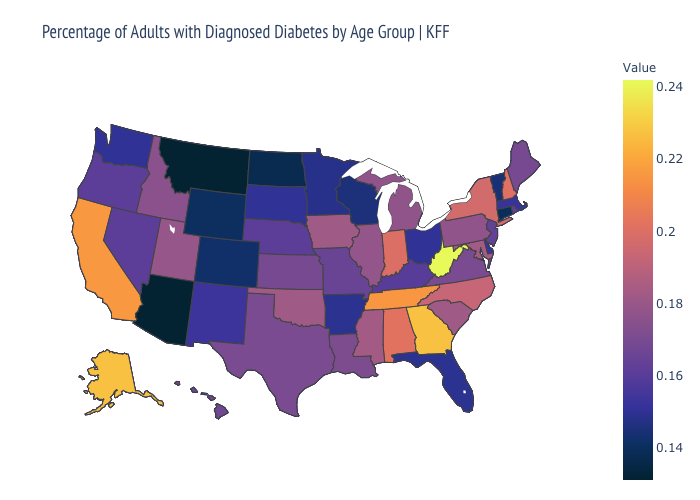Which states have the lowest value in the USA?
Give a very brief answer. Arizona, Montana. Among the states that border Florida , which have the lowest value?
Short answer required. Alabama. Which states have the lowest value in the West?
Answer briefly. Arizona, Montana. Among the states that border Texas , which have the highest value?
Concise answer only. Oklahoma. Does West Virginia have the highest value in the South?
Keep it brief. Yes. Does Connecticut have the lowest value in the Northeast?
Concise answer only. Yes. Among the states that border Ohio , which have the lowest value?
Give a very brief answer. Kentucky. Among the states that border Texas , which have the highest value?
Keep it brief. Oklahoma. 